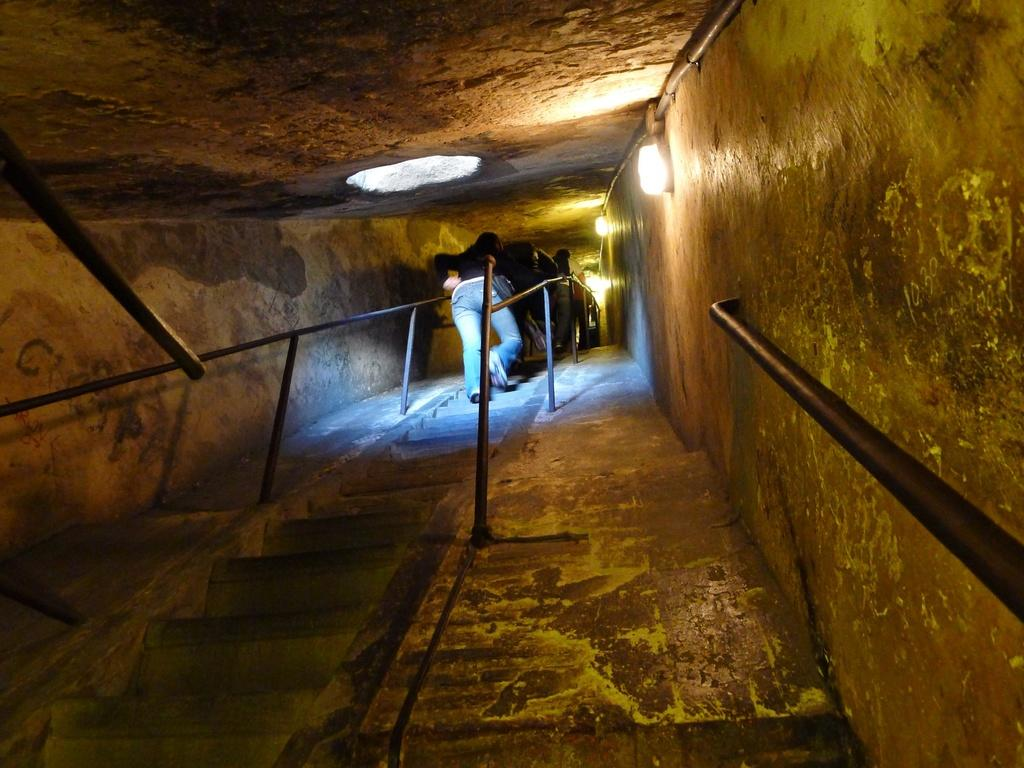What is the main feature of the image? There is a tunnel in the image. What can be found inside the tunnel? The tunnel has steps inside it and also has railing. What are the people in the image doing? There are people walking in the tunnel. What is present near the tunnel? There are lights beside the tunnel. Is there any damage to the tunnel? Yes, there is a hole in the ceiling of the tunnel. What type of pickle is hanging from the railing in the image? There is no pickle present in the image; it features a tunnel with steps, railing, and people walking. How does the nerve affect the tunnel's structure in the image? There is no mention of a nerve in the image, and it does not affect the tunnel's structure. 